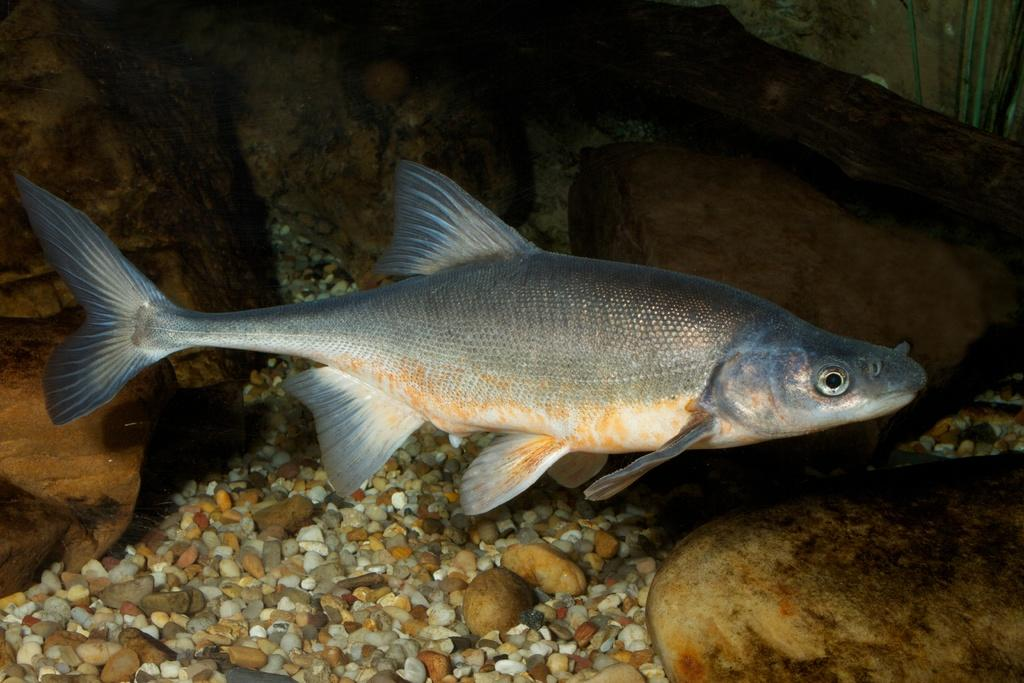What type of animal is in the image? There is a fish in the image. What colors can be seen on the fish? The fish has grey, cream, orange, and black colors. What other objects are in the image besides the fish? There are stones and rocks in the image. What colors can be seen on the stones and rocks? The stones and rocks have cream, brown, and orange colors. Can you hear the hydrant crying in the image? There is no hydrant present in the image, and therefore it cannot be heard crying. What type of wire is connected to the fish in the image? There is no wire connected to the fish in the image. 